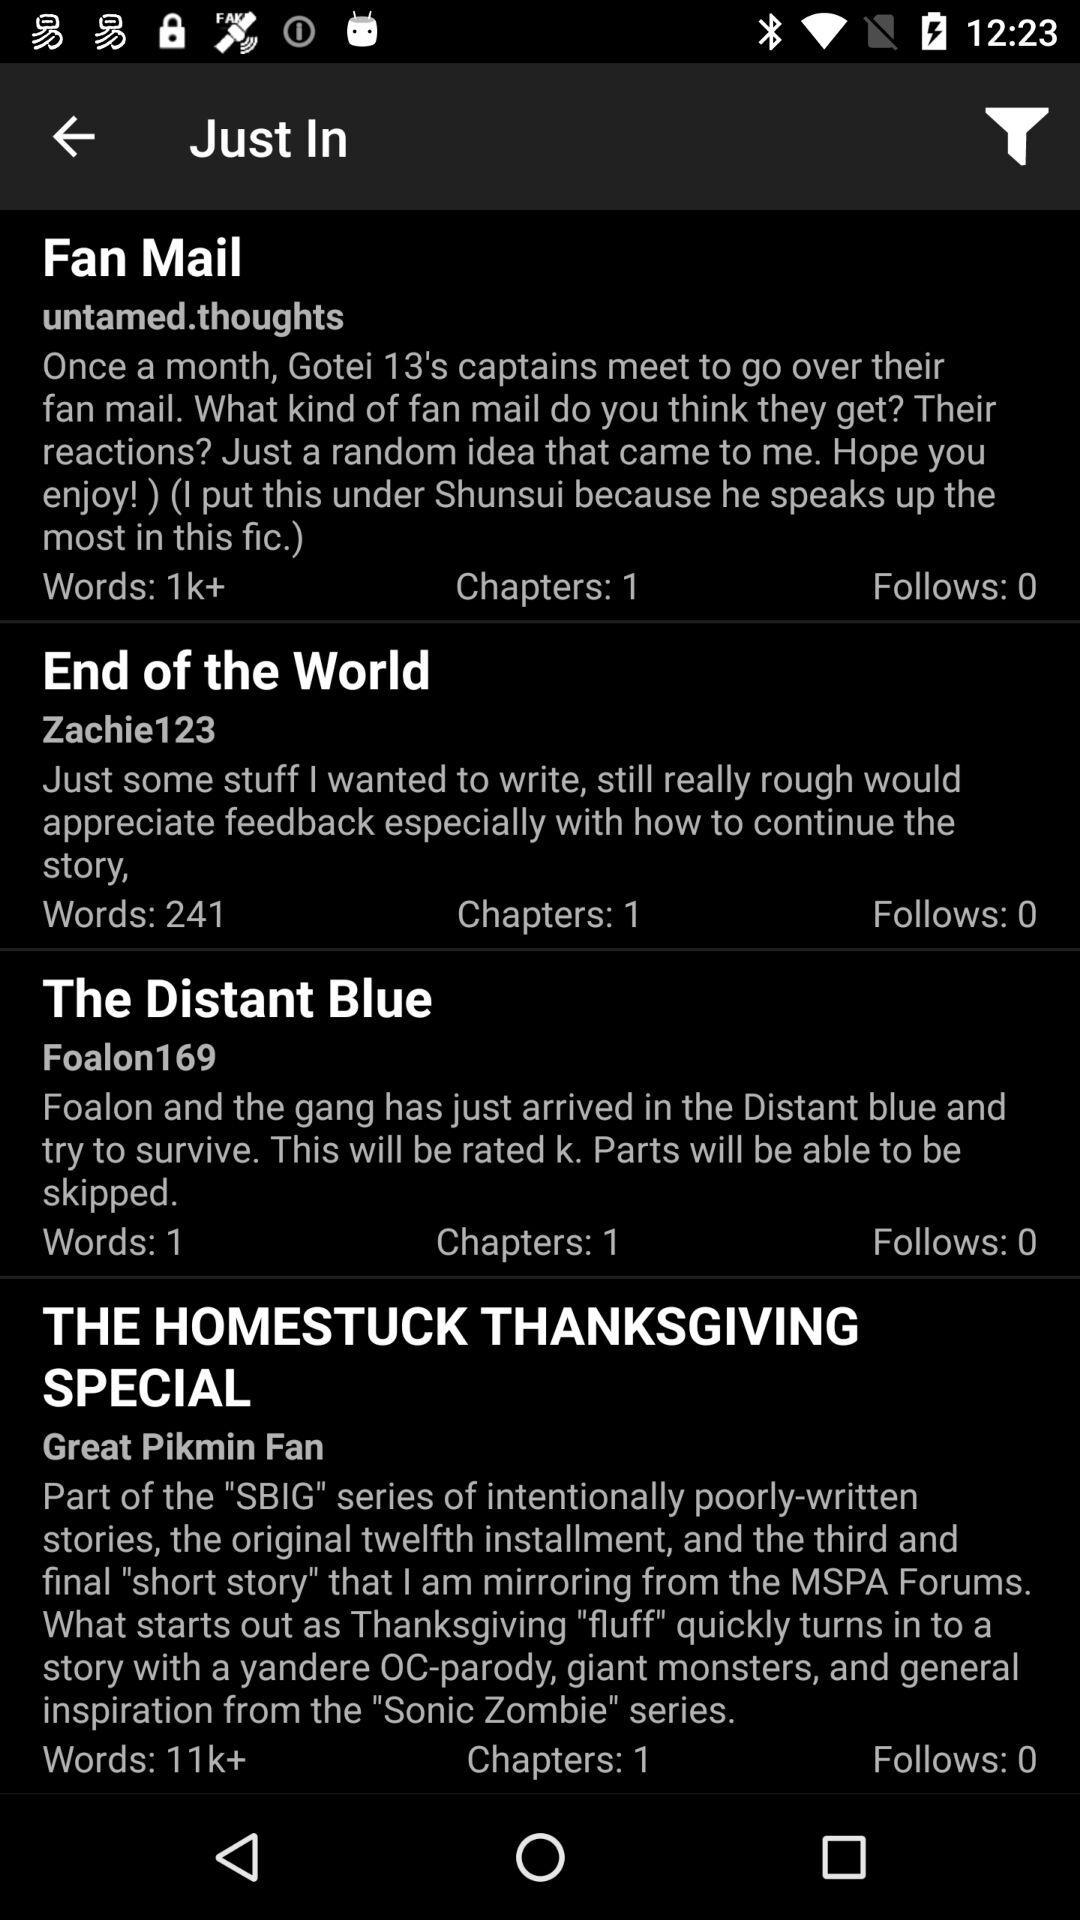For which article 11k+ words are given? The article is "THE HOMESTUCK THANKSGIVING SPECIAL". 